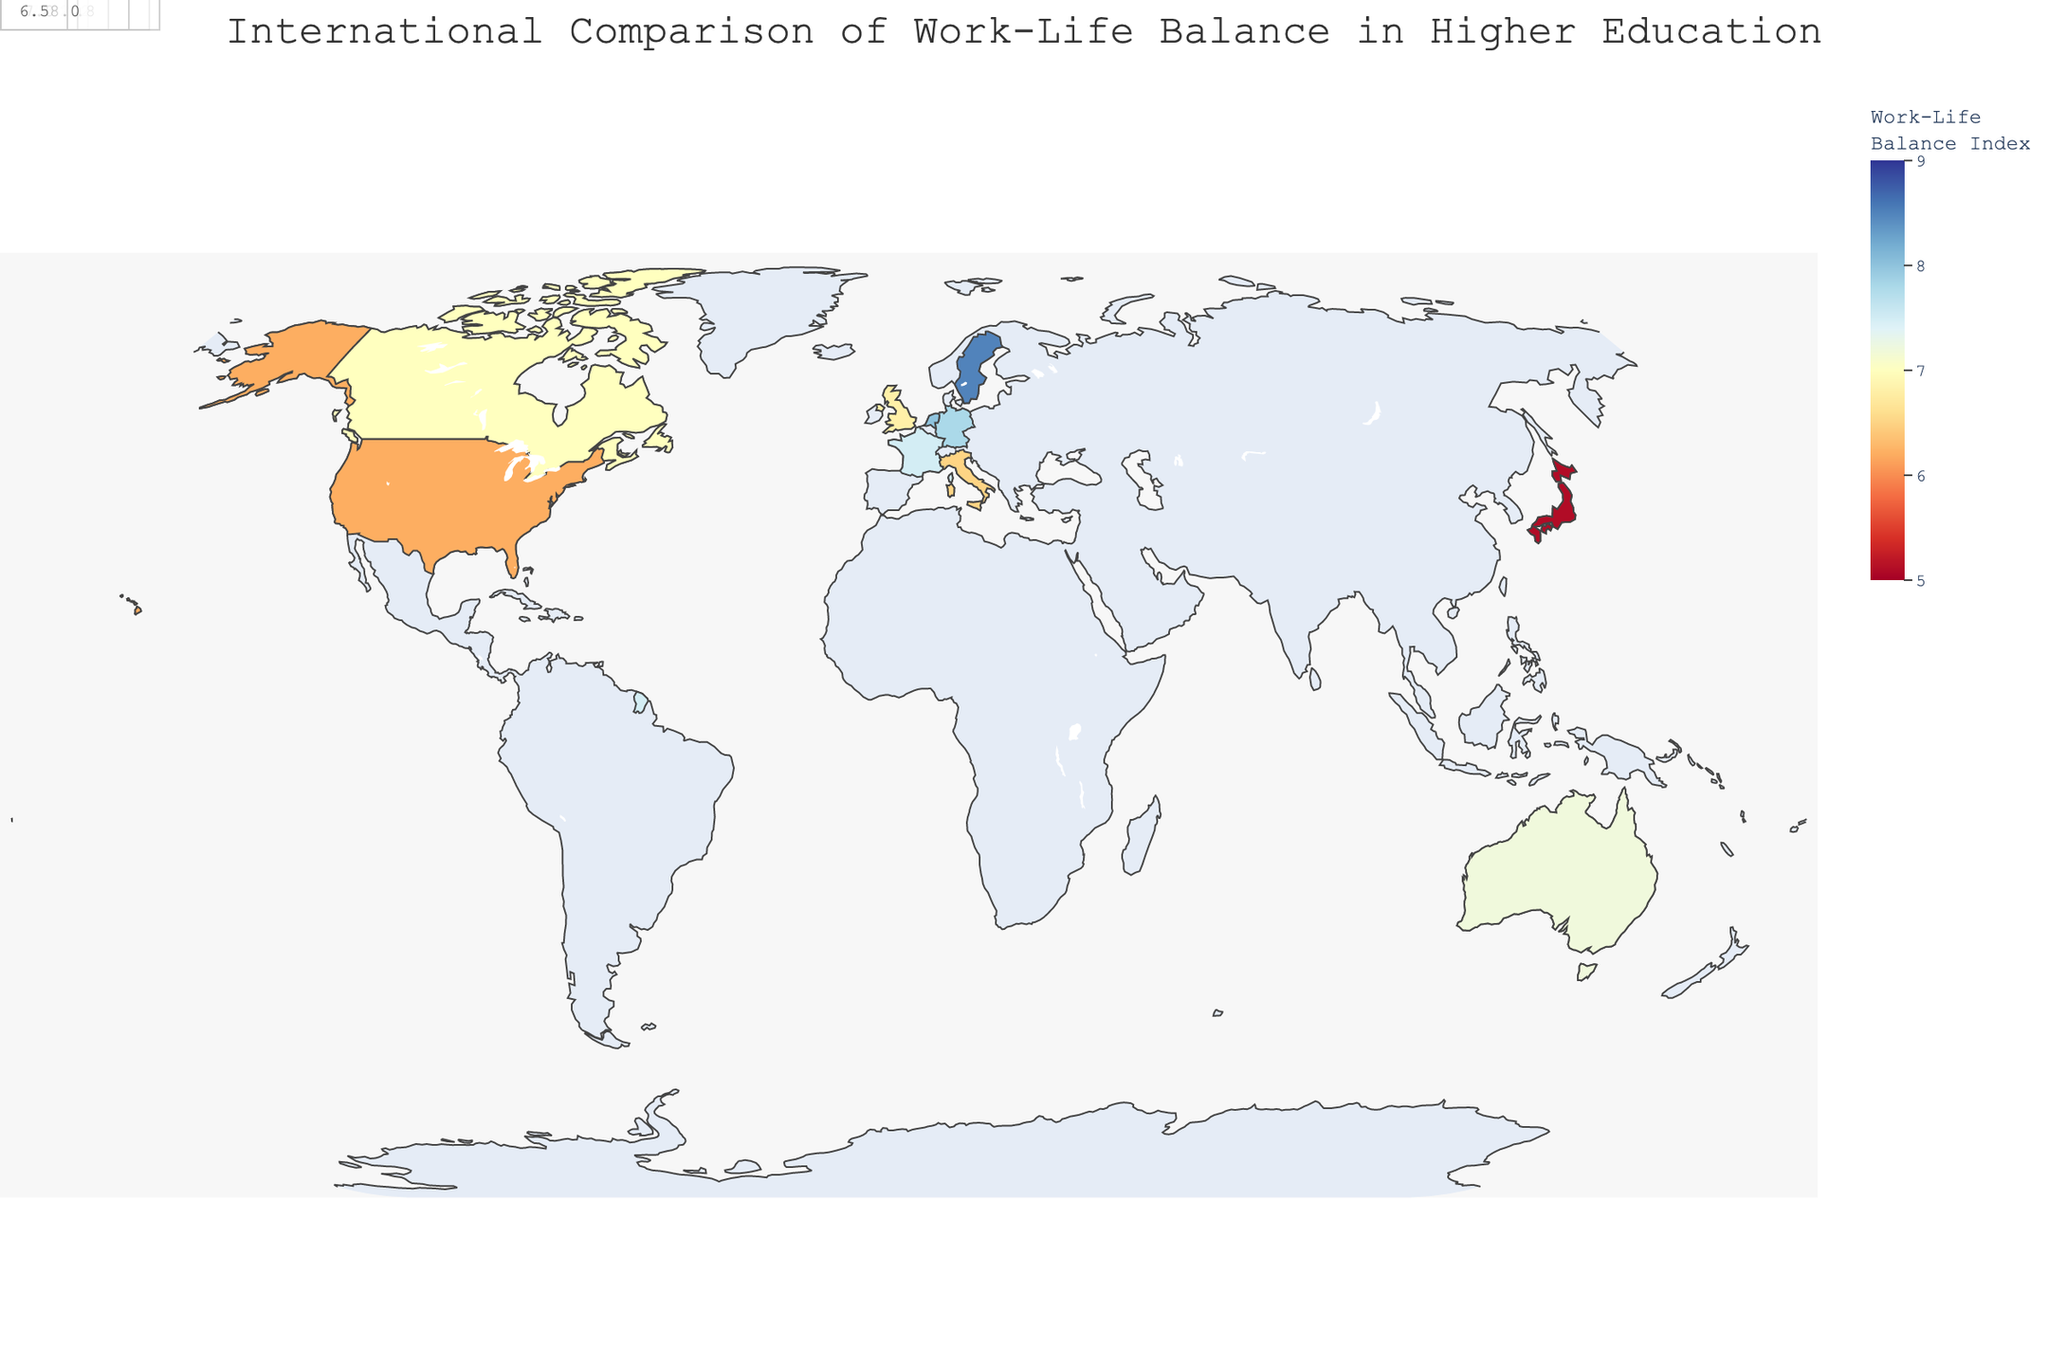what is the Work-Life Balance Index for Sweden? The map uses color intensity to represent the Work-Life Balance Index for each country. By looking at the country marked "Sweden", we can hover over it to see the exact value.
Answer: 8.5 Which country has the highest Work-Life Balance Index? To identify which country has the highest index, refer to the country with the most intense color signifying the highest index in the legend. On hovering, we see that Sweden has the highest index value.
Answer: Sweden What is the difference in Work-Life Balance Index between Germany and the United States? Identify the Work-Life Balance Index for both Germany (7.8) and the United States (6.2) from the map. Subtract the lower value from the higher value: 7.8 - 6.2 = 1.6.
Answer: 1.6 What two countries have the closest Work-Life Balance Index values? Compare the indices visually or by hovering over each country. Netherlands (8.0) and Germany (7.8) have the closest values, a difference of 0.2.
Answer: Netherlands and Germany Which country has the lowest value on the Work-Life Balance Index? Refer to the country with the least intense color representing the Work-Life Balance Index in the legend. Hovering over Japan reveals it has the lowest index value.
Answer: Japan What is the average Work-Life Balance Index of all the countries? To find the average, add all the index values (6.2 + 7.8 + 5.1 + 6.8 + 8.5 + 7.2 + 7.5 + 7.0 + 8.0 + 6.5 = 70.6) and divide by the number of countries (10). The average is 70.6/10 = 7.06.
Answer: 7.06 Which countries have a Work-Life Balance Index greater than 7? By scanning the map, find and list the countries with index values over 7. These countries are Germany, Sweden, Australia, France, Netherlands, and Canada.
Answer: Germany, Sweden, Australia, France, Netherlands, Canada How does the Work-Life Balance Index for the Netherlands compare to that of Italy? The Netherlands has a Work-Life Balance Index of 8.0, whereas Italy has 6.5. Therefore, the Netherlands' index is higher.
Answer: Netherlands is higher What is the range of the Work-Life Balance Index values displayed on the map? The range is the difference between the highest and lowest values. The highest is Sweden (8.5) and the lowest is Japan (5.1). The range is 8.5 - 5.1 = 3.4.
Answer: 3.4 How does the Academic Freedom Score correlate with the Work-Life Balance Index on this map? Hover to observe individual data points: countries with high work-life balance tend to have higher Academic Freedom Scores (e.g., Sweden and Netherlands). Conversely, those with low work-life balance like Japan have lower Academic Freedom. This indicates a positive correlation.
Answer: Positive correlation 